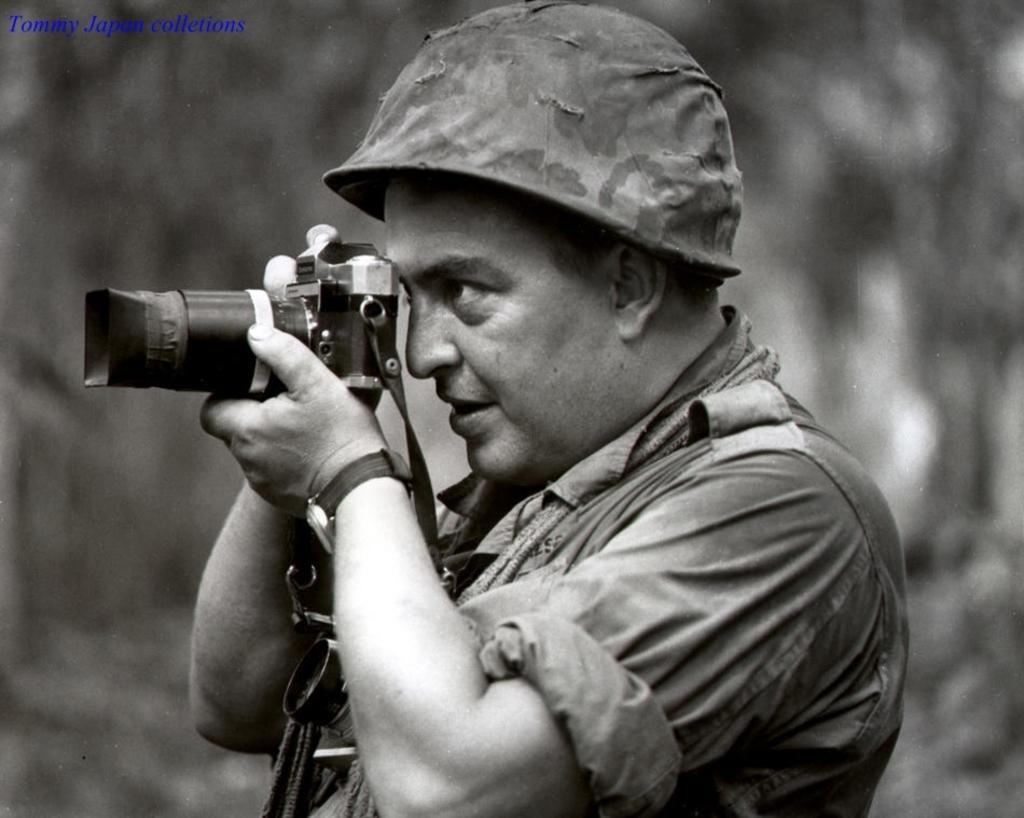What is the main subject of the image? There is a person in the image. What is the person doing in the image? The person is holding a camera and taking a picture. Can you describe the background of the image? The background of the image is blurry. What type of cart is the queen riding in the image? There is no cart or queen present in the image; it features a person holding a camera and taking a picture. 